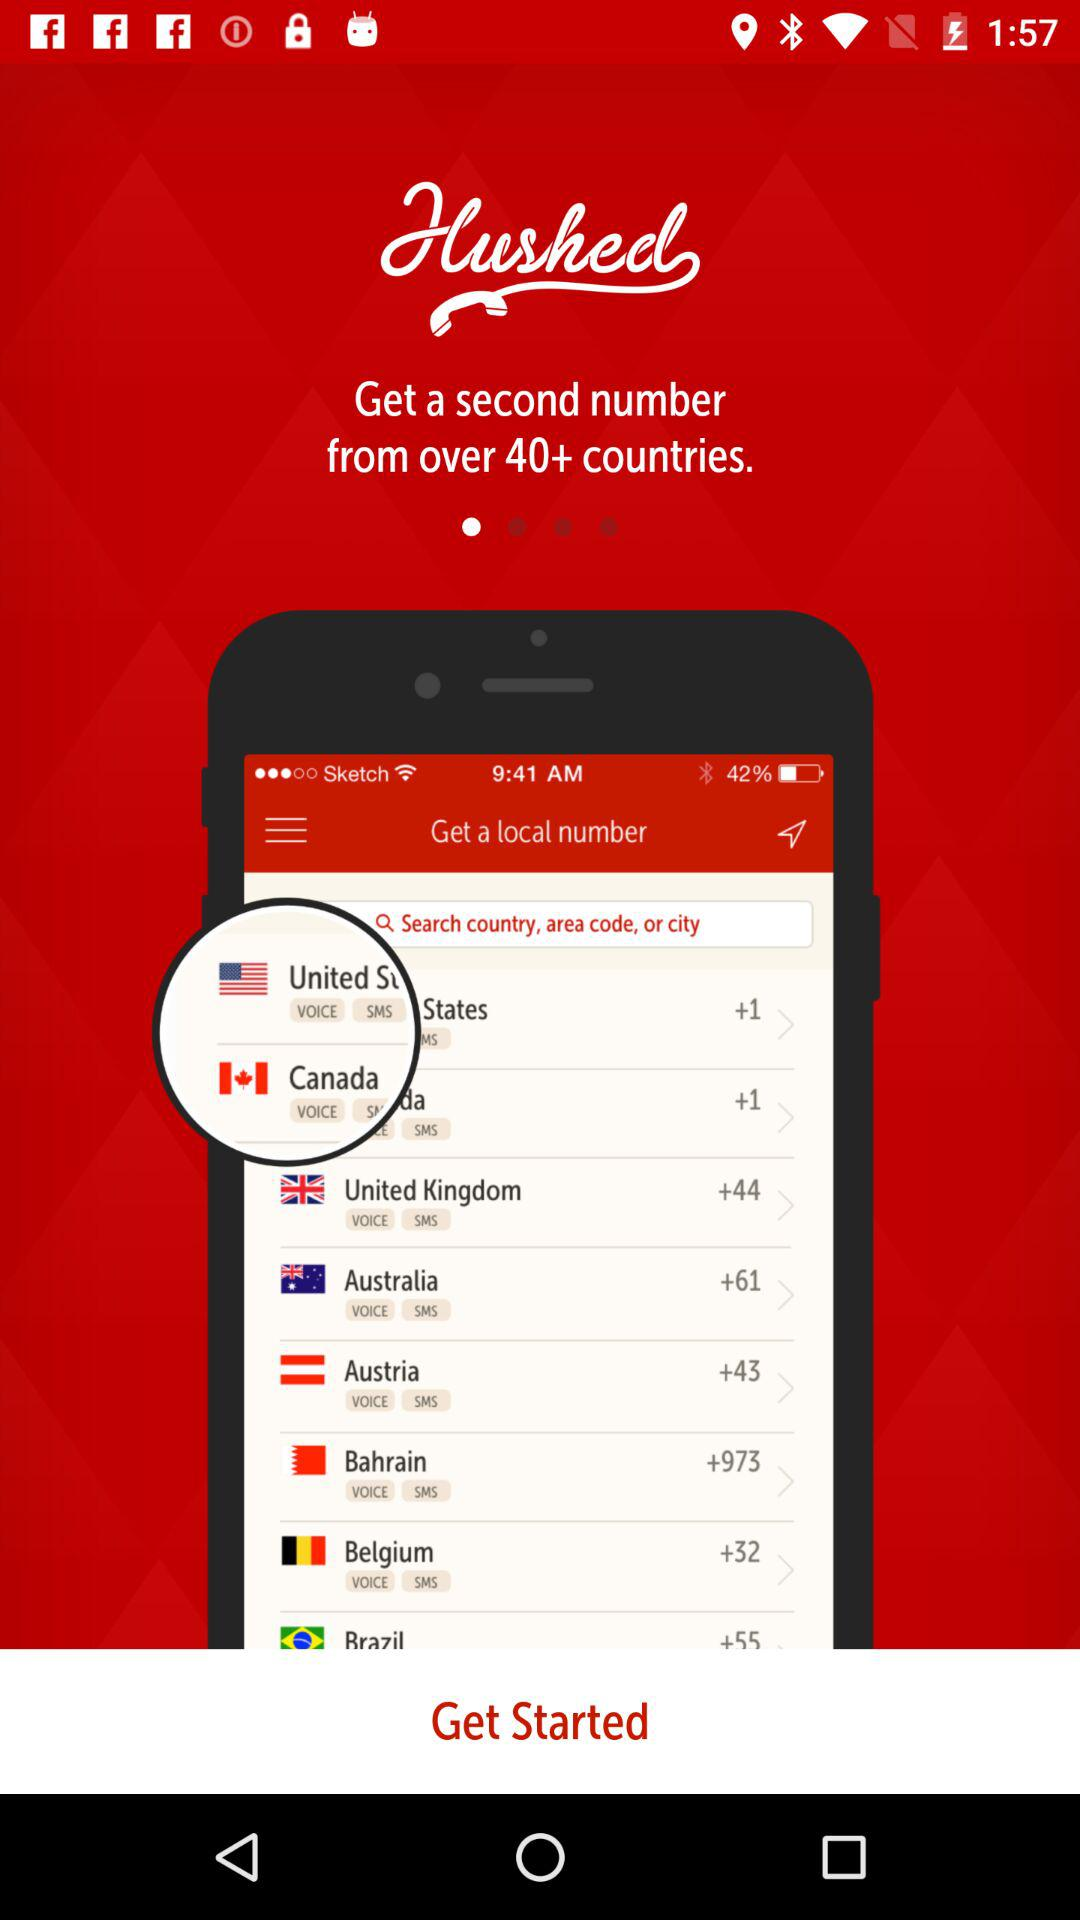What is the application name? The application name is "Hushed". 